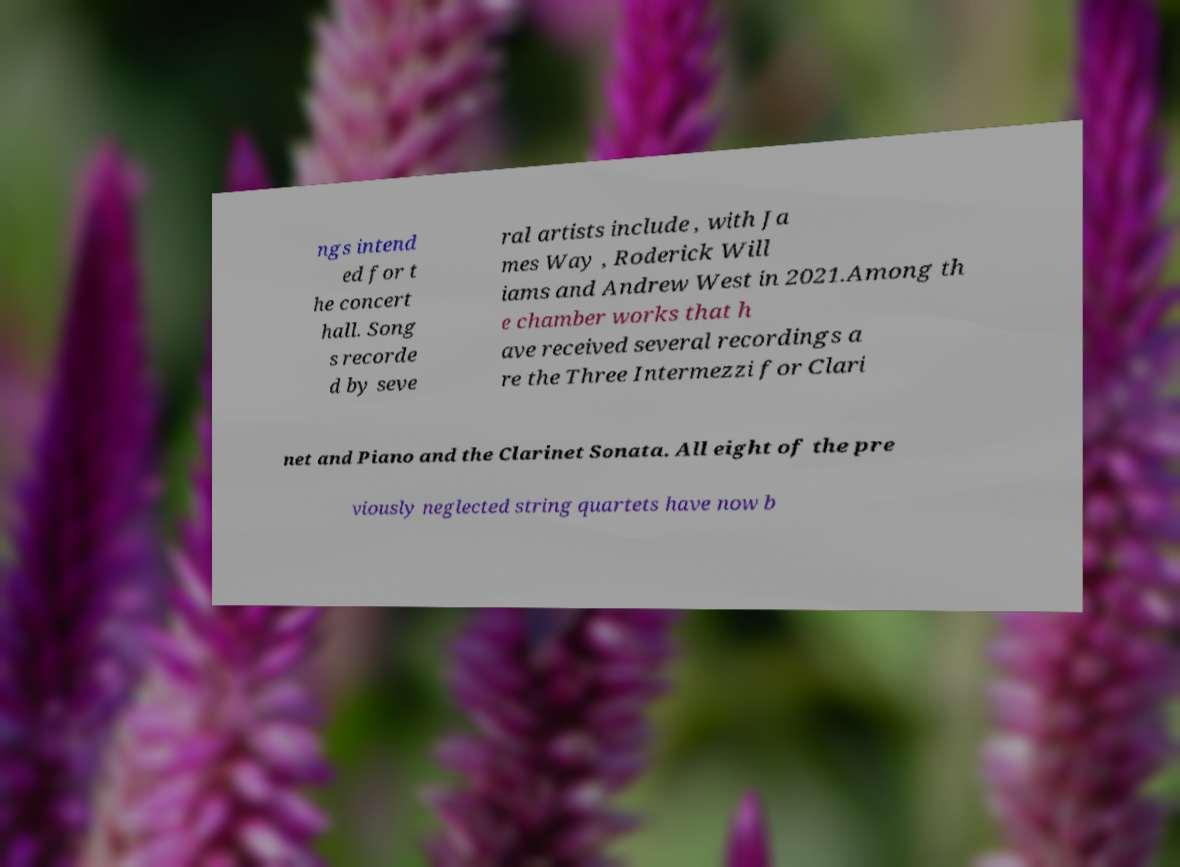Can you read and provide the text displayed in the image?This photo seems to have some interesting text. Can you extract and type it out for me? ngs intend ed for t he concert hall. Song s recorde d by seve ral artists include , with Ja mes Way , Roderick Will iams and Andrew West in 2021.Among th e chamber works that h ave received several recordings a re the Three Intermezzi for Clari net and Piano and the Clarinet Sonata. All eight of the pre viously neglected string quartets have now b 